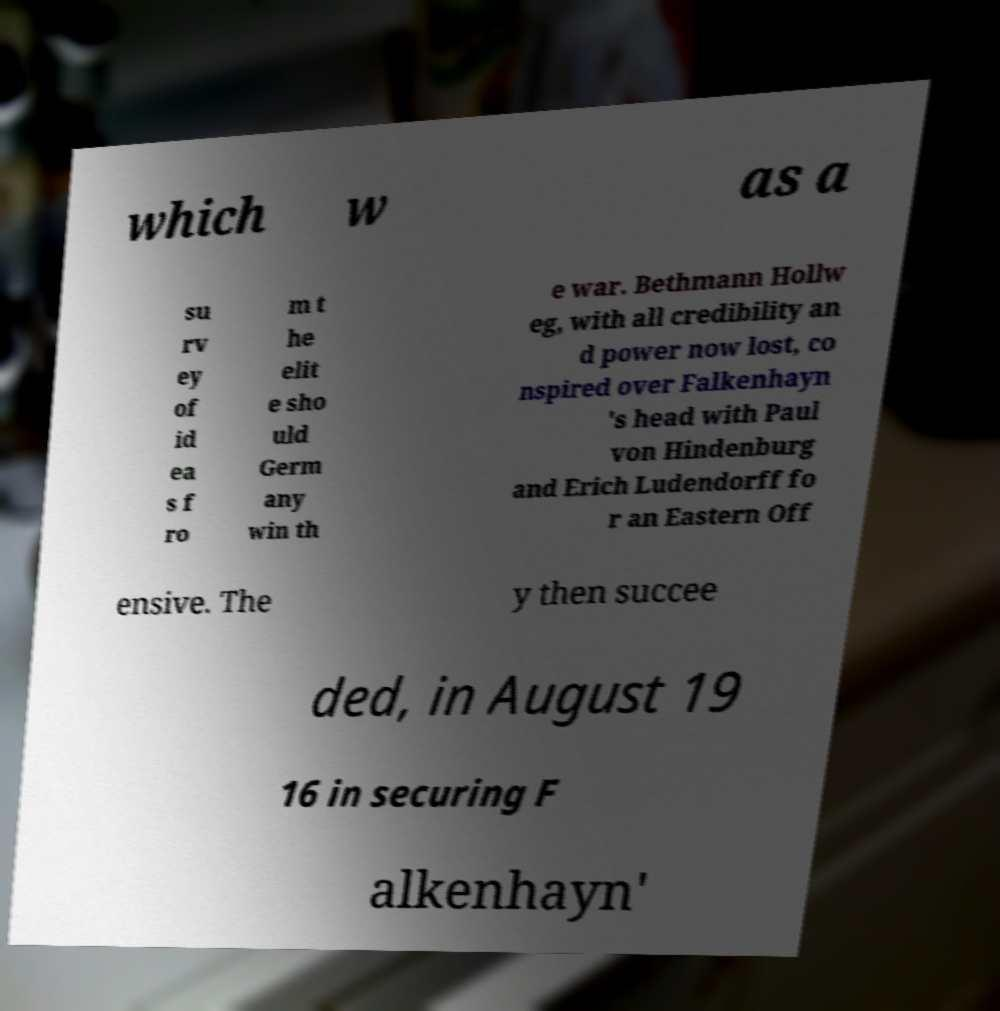There's text embedded in this image that I need extracted. Can you transcribe it verbatim? which w as a su rv ey of id ea s f ro m t he elit e sho uld Germ any win th e war. Bethmann Hollw eg, with all credibility an d power now lost, co nspired over Falkenhayn 's head with Paul von Hindenburg and Erich Ludendorff fo r an Eastern Off ensive. The y then succee ded, in August 19 16 in securing F alkenhayn' 